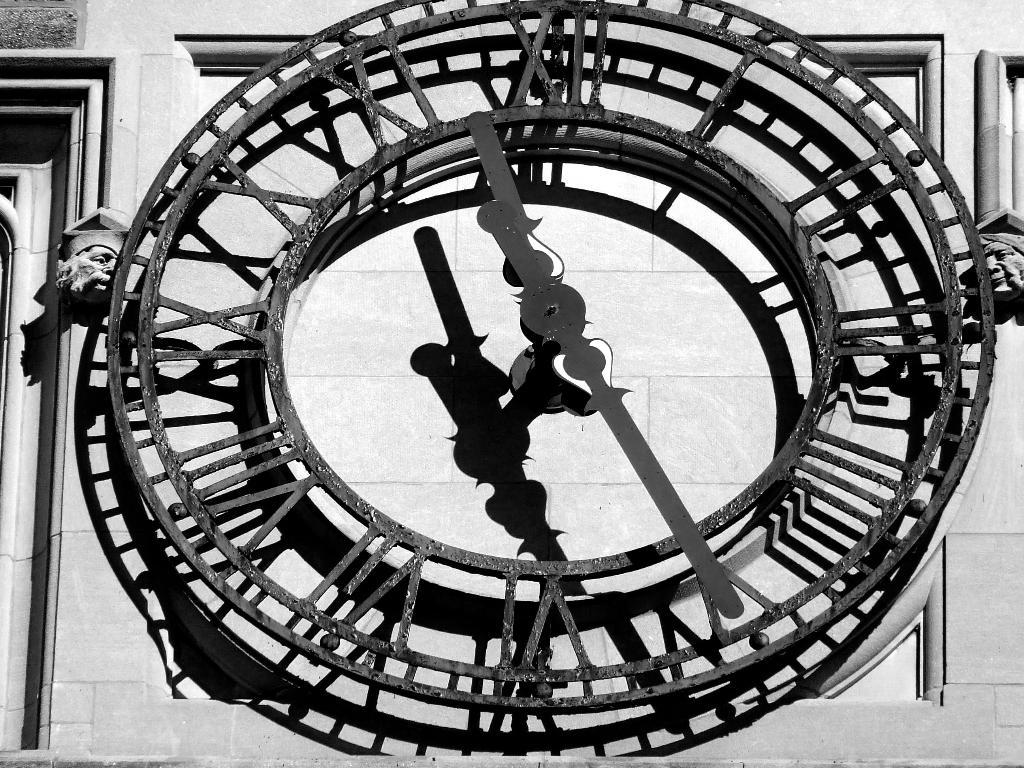What object is the main focus of the picture? There is a clock in the picture. What features does the clock have? The clock has minute and hour hands, a frame, and numbers. What is visible in the background of the picture? There is a wall in the backdrop of the picture. Are there any dinosaurs visible in the picture? No, there are no dinosaurs present in the image. Is the clock located inside a jail in the picture? There is no indication of a jail or any related context in the image; it only features a clock and a wall in the background. 